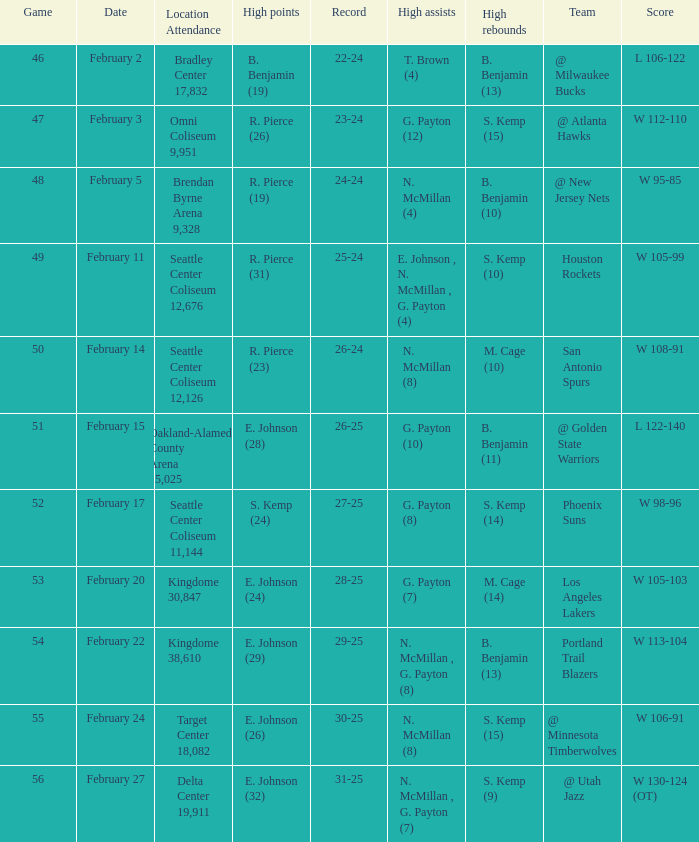Which game had a score of w 95-85? 48.0. 